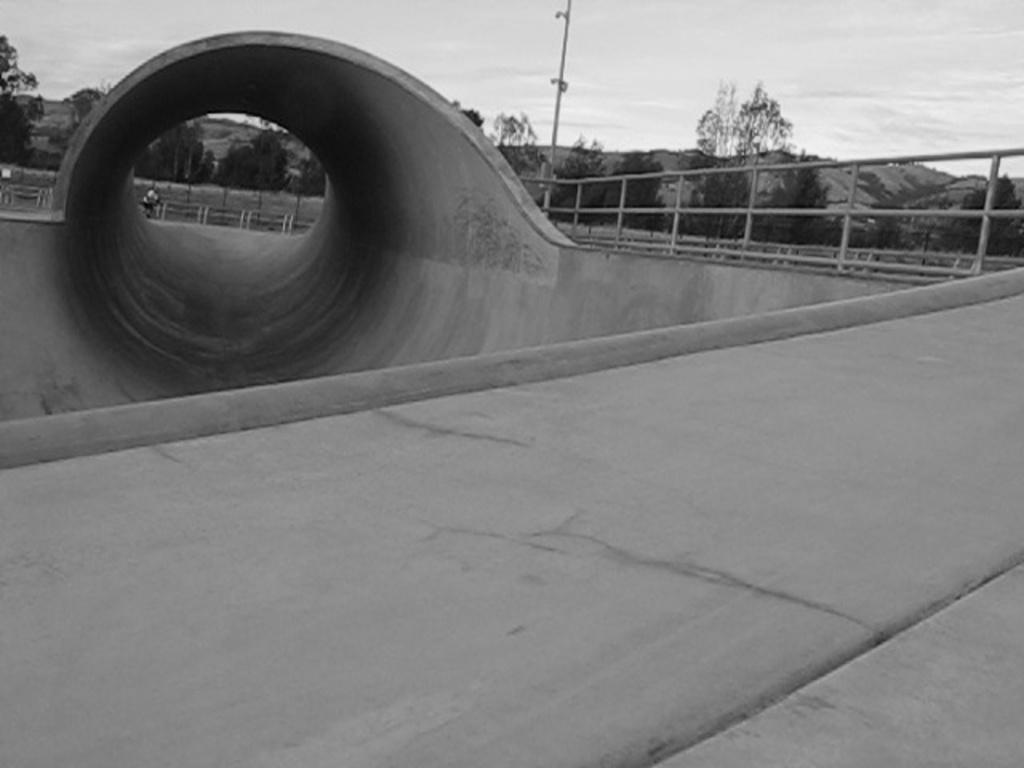Can you describe this image briefly? In this black and white image, we can see a bridge. There is a tunnel in the top left of the image. There are some trees and sky at the top of the image. 